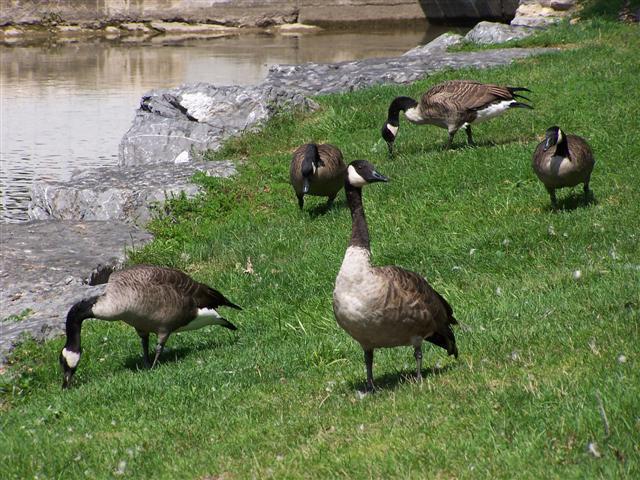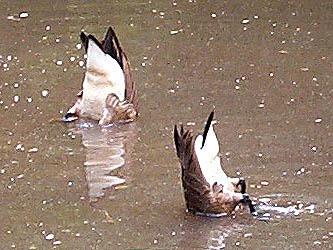The first image is the image on the left, the second image is the image on the right. Analyze the images presented: Is the assertion "in at least one image there are geese eating the grass" valid? Answer yes or no. Yes. The first image is the image on the left, the second image is the image on the right. Given the left and right images, does the statement "One image has water fowl in the water." hold true? Answer yes or no. Yes. 